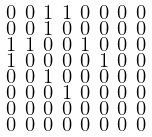<formula> <loc_0><loc_0><loc_500><loc_500>\begin{smallmatrix} 0 & 0 & 1 & 1 & 0 & 0 & 0 & 0 \\ 0 & 0 & 1 & 0 & 0 & 0 & 0 & 0 \\ 1 & 1 & 0 & 0 & 1 & 0 & 0 & 0 \\ 1 & 0 & 0 & 0 & 0 & 1 & 0 & 0 \\ 0 & 0 & 1 & 0 & 0 & 0 & 0 & 0 \\ 0 & 0 & 0 & 1 & 0 & 0 & 0 & 0 \\ 0 & 0 & 0 & 0 & 0 & 0 & 0 & 0 \\ 0 & 0 & 0 & 0 & 0 & 0 & 0 & 0 \end{smallmatrix}</formula> 